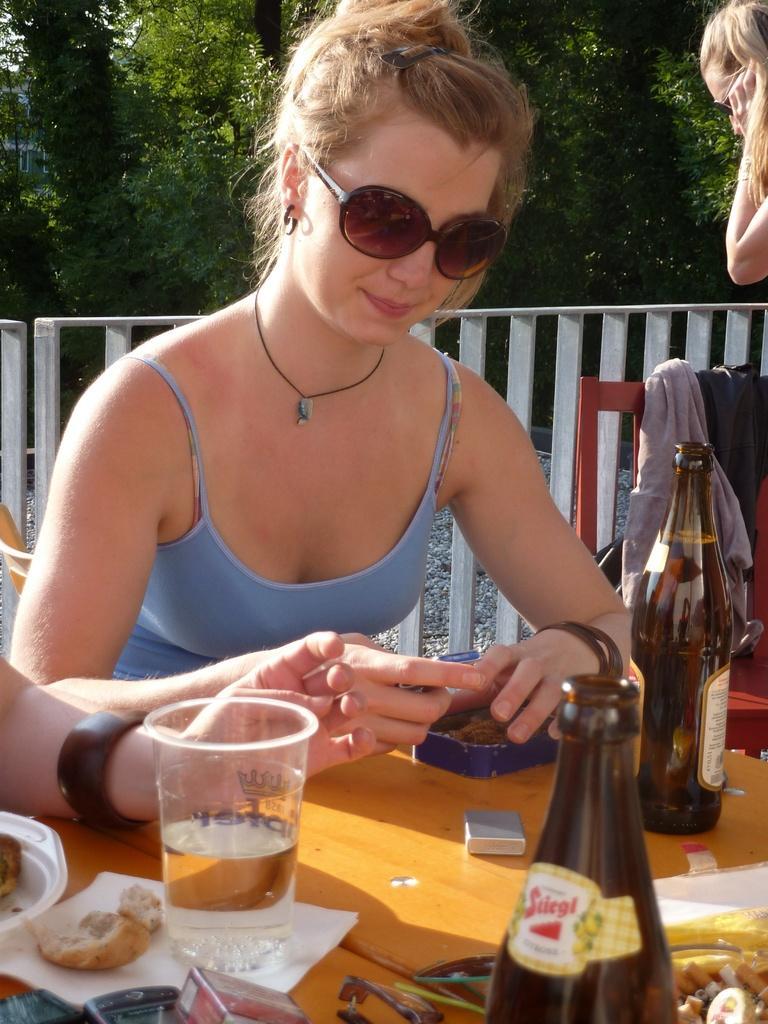Could you give a brief overview of what you see in this image? Here we can see a woman wearing goggles sitting on chair with table in front of her having bottles of beer, glasses of water and something to eat on it and behind have we can see trees present 